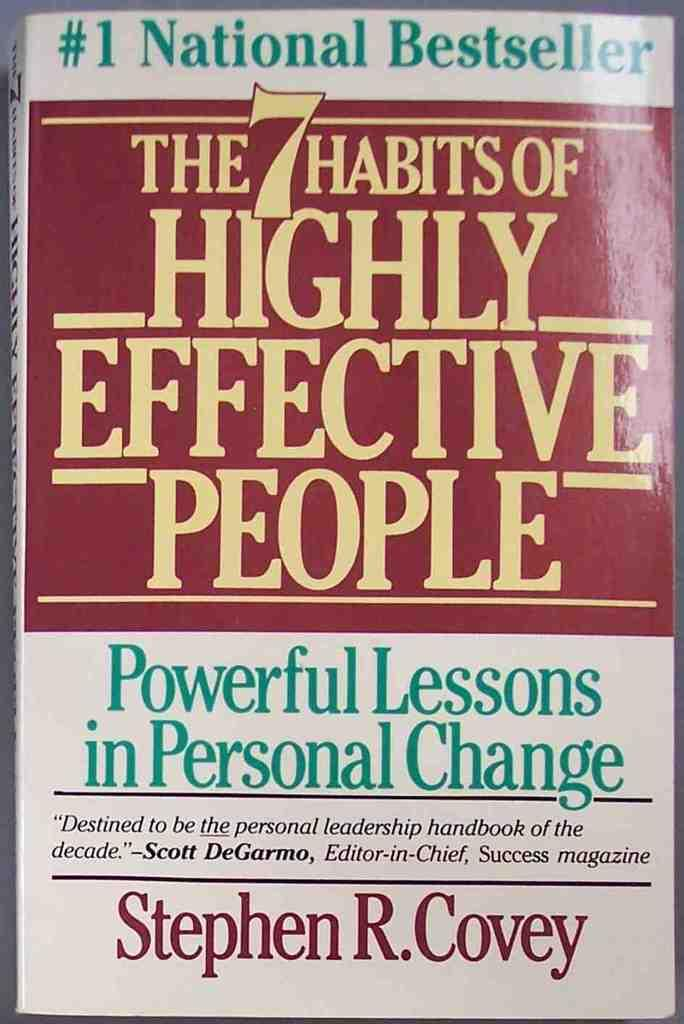Provide a one-sentence caption for the provided image. the cover of a book called 'the 7 habits of highly effective people'. 